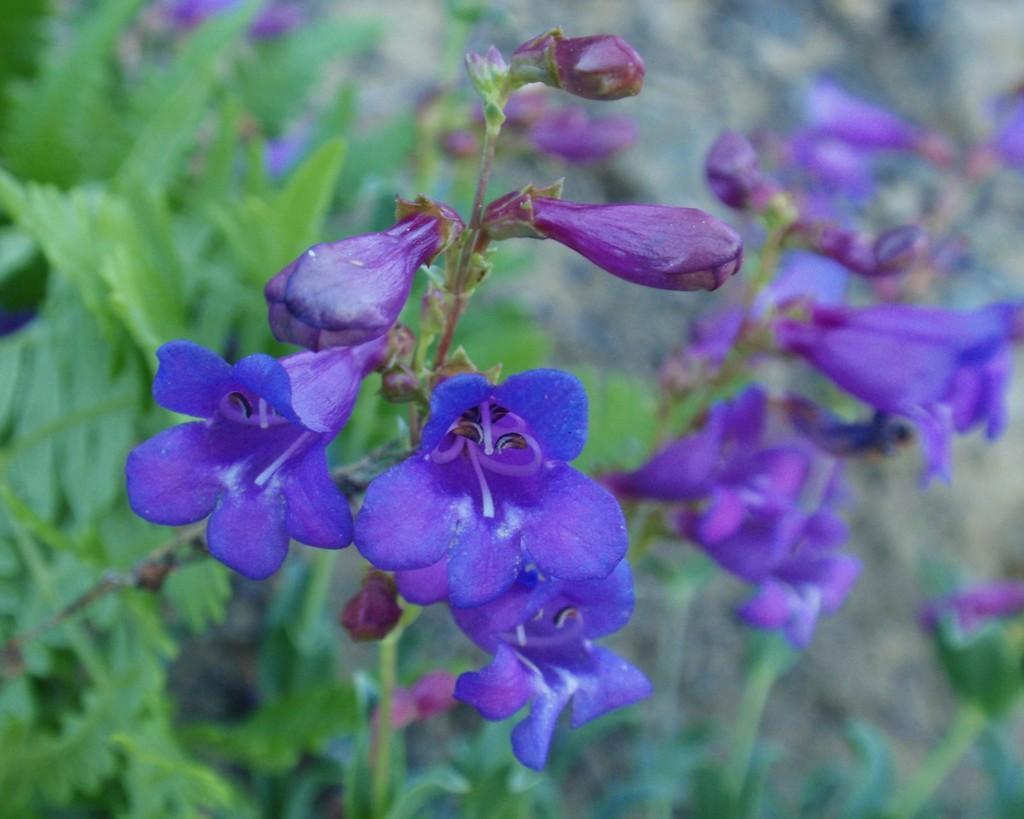Could you give a brief overview of what you see in this image? In this image, I can see flowering plants. This image taken, maybe in a garden. 